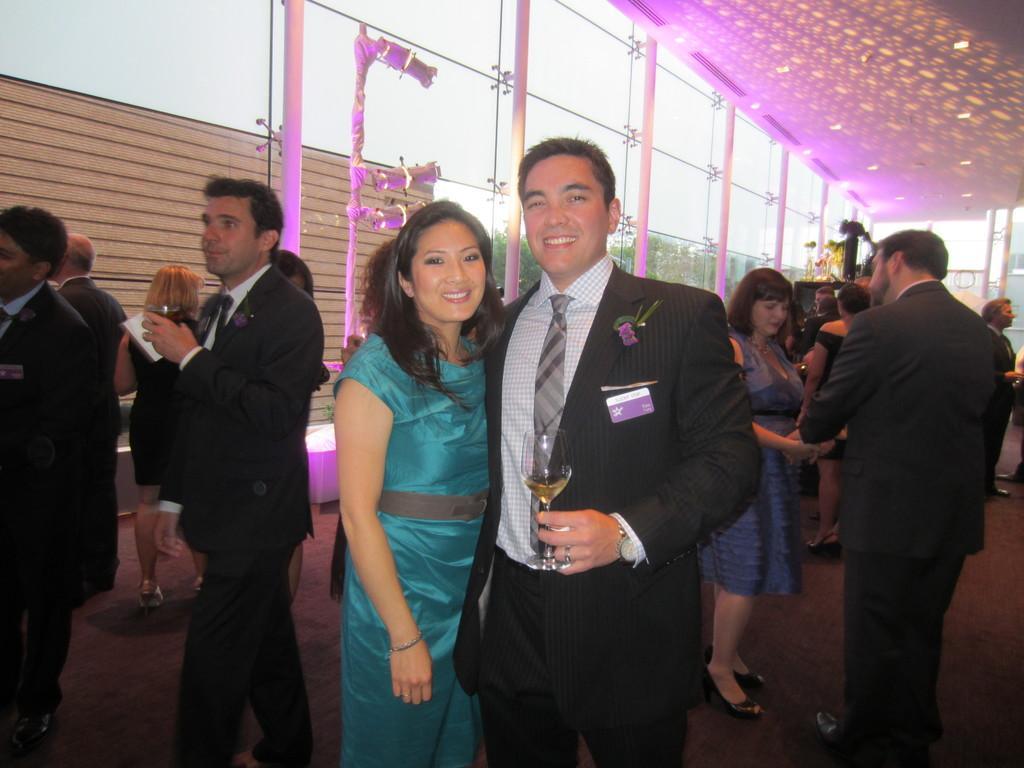Please provide a concise description of this image. In this image we can see a group of persons and among them few persons are holding objects. Behind the persons we can see a glass wall and poles. Through the glass we can see trees and a brown object. At the top we can see the sky. In the top right, we can see the roof. 